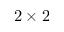Convert formula to latex. <formula><loc_0><loc_0><loc_500><loc_500>2 \times 2</formula> 